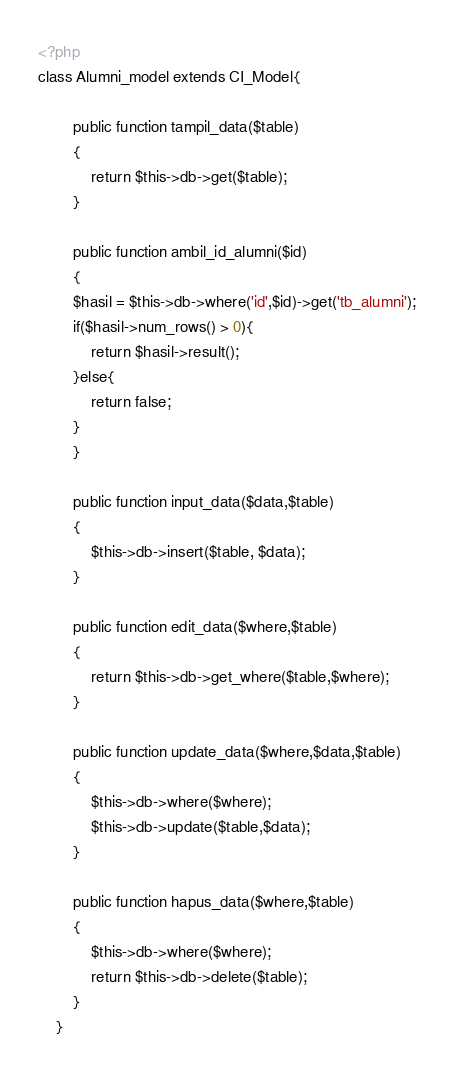Convert code to text. <code><loc_0><loc_0><loc_500><loc_500><_PHP_><?php
class Alumni_model extends CI_Model{

		public function tampil_data($table)
		{
			return $this->db->get($table);
		}

		public function ambil_id_alumni($id)
		{
		$hasil = $this->db->where('id',$id)->get('tb_alumni');
		if($hasil->num_rows() > 0){
			return $hasil->result();
		}else{
			return false;
		}
		}

		public function input_data($data,$table)
		{
			$this->db->insert($table, $data);
		}

		public function edit_data($where,$table)
		{
			return $this->db->get_where($table,$where);
		}

		public function update_data($where,$data,$table)
		{
			$this->db->where($where);
			$this->db->update($table,$data);
		}	
		
		public function hapus_data($where,$table)
		{
			$this->db->where($where);
			return $this->db->delete($table);
		}
	}</code> 